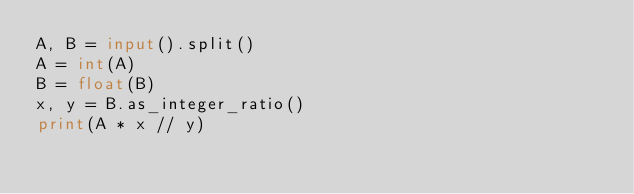Convert code to text. <code><loc_0><loc_0><loc_500><loc_500><_Python_>A, B = input().split()
A = int(A)
B = float(B)
x, y = B.as_integer_ratio()
print(A * x // y)</code> 